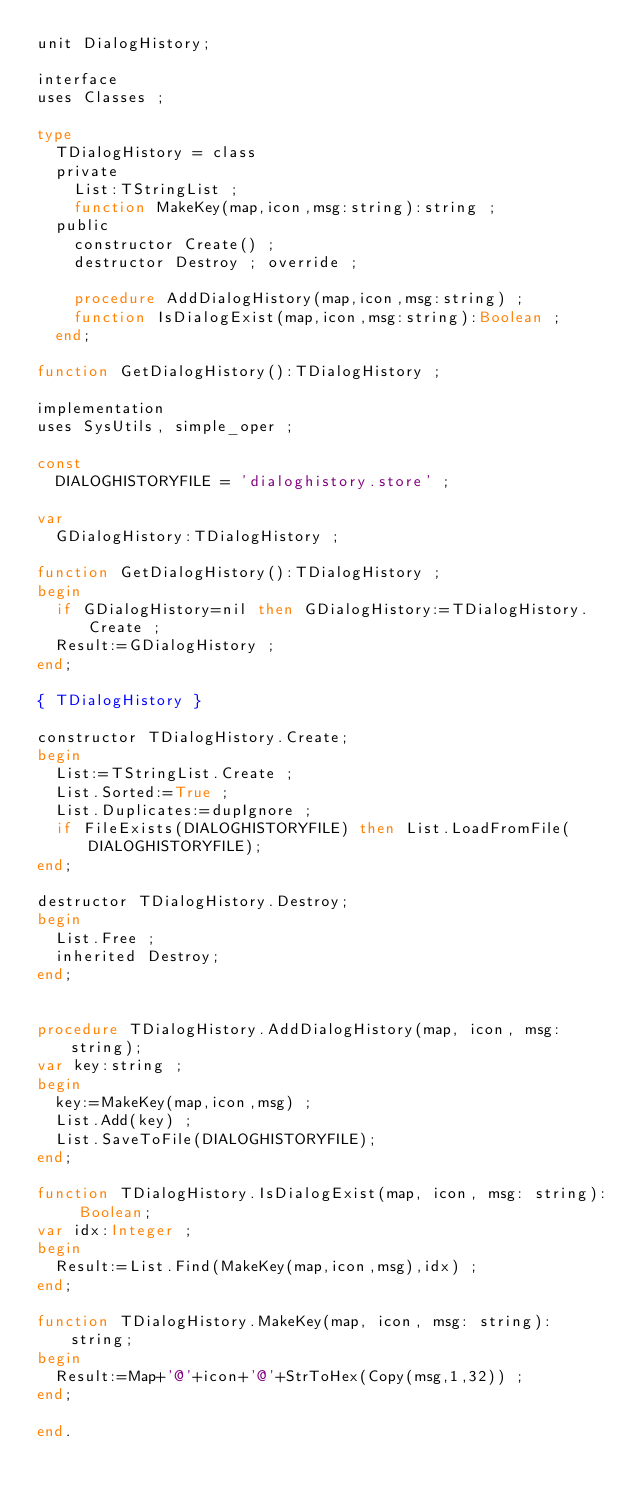<code> <loc_0><loc_0><loc_500><loc_500><_Pascal_>unit DialogHistory;

interface
uses Classes ;

type
  TDialogHistory = class
  private
    List:TStringList ;
    function MakeKey(map,icon,msg:string):string ;
  public
    constructor Create() ;
    destructor Destroy ; override ;

    procedure AddDialogHistory(map,icon,msg:string) ;
    function IsDialogExist(map,icon,msg:string):Boolean ;
  end;

function GetDialogHistory():TDialogHistory ;

implementation
uses SysUtils, simple_oper ;

const
  DIALOGHISTORYFILE = 'dialoghistory.store' ;

var
  GDialogHistory:TDialogHistory ;

function GetDialogHistory():TDialogHistory ;
begin
  if GDialogHistory=nil then GDialogHistory:=TDialogHistory.Create ;
  Result:=GDialogHistory ;
end;

{ TDialogHistory }

constructor TDialogHistory.Create;
begin
  List:=TStringList.Create ;
  List.Sorted:=True ;
  List.Duplicates:=dupIgnore ;
  if FileExists(DIALOGHISTORYFILE) then List.LoadFromFile(DIALOGHISTORYFILE);
end;

destructor TDialogHistory.Destroy;
begin
  List.Free ;
  inherited Destroy;
end;


procedure TDialogHistory.AddDialogHistory(map, icon, msg: string);
var key:string ;
begin
  key:=MakeKey(map,icon,msg) ;
  List.Add(key) ;
  List.SaveToFile(DIALOGHISTORYFILE);
end;

function TDialogHistory.IsDialogExist(map, icon, msg: string): Boolean;
var idx:Integer ;
begin
  Result:=List.Find(MakeKey(map,icon,msg),idx) ;
end;

function TDialogHistory.MakeKey(map, icon, msg: string): string;
begin
  Result:=Map+'@'+icon+'@'+StrToHex(Copy(msg,1,32)) ;
end;

end.
</code> 